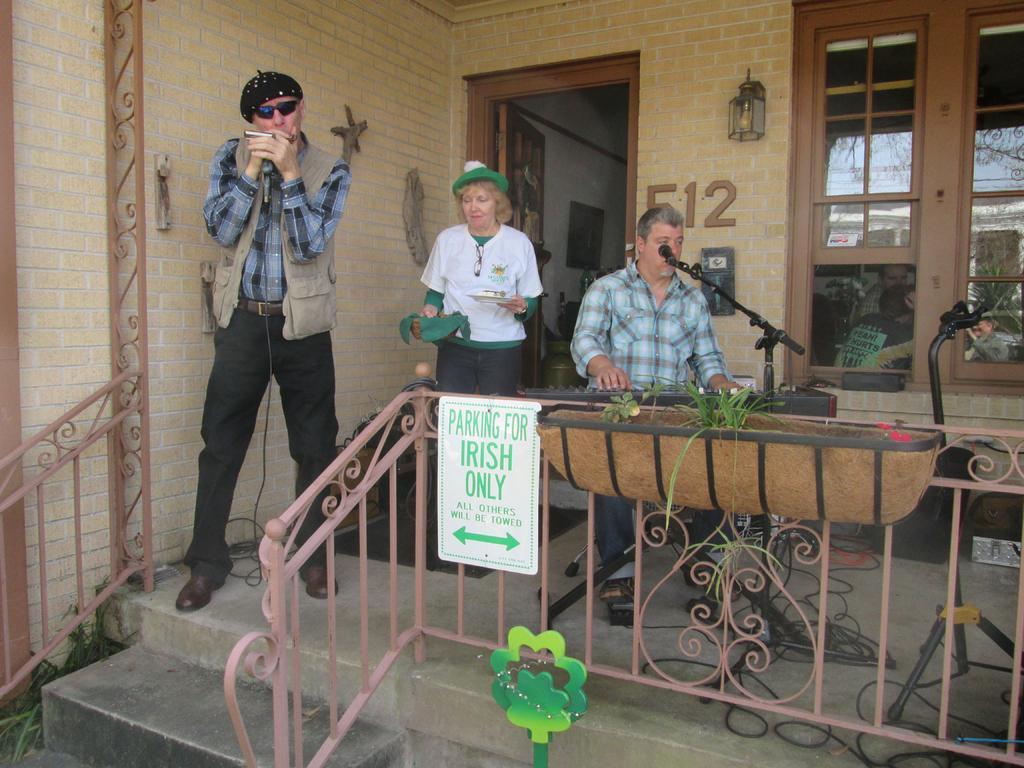How would you summarize this image in a sentence or two? This is a image of a building. In the foreground of the picture there are group of people, mic, musical instrument, plant, railing, board, cables and other objects. On the right there are windows. In the center the background there is a door and there are lights. 